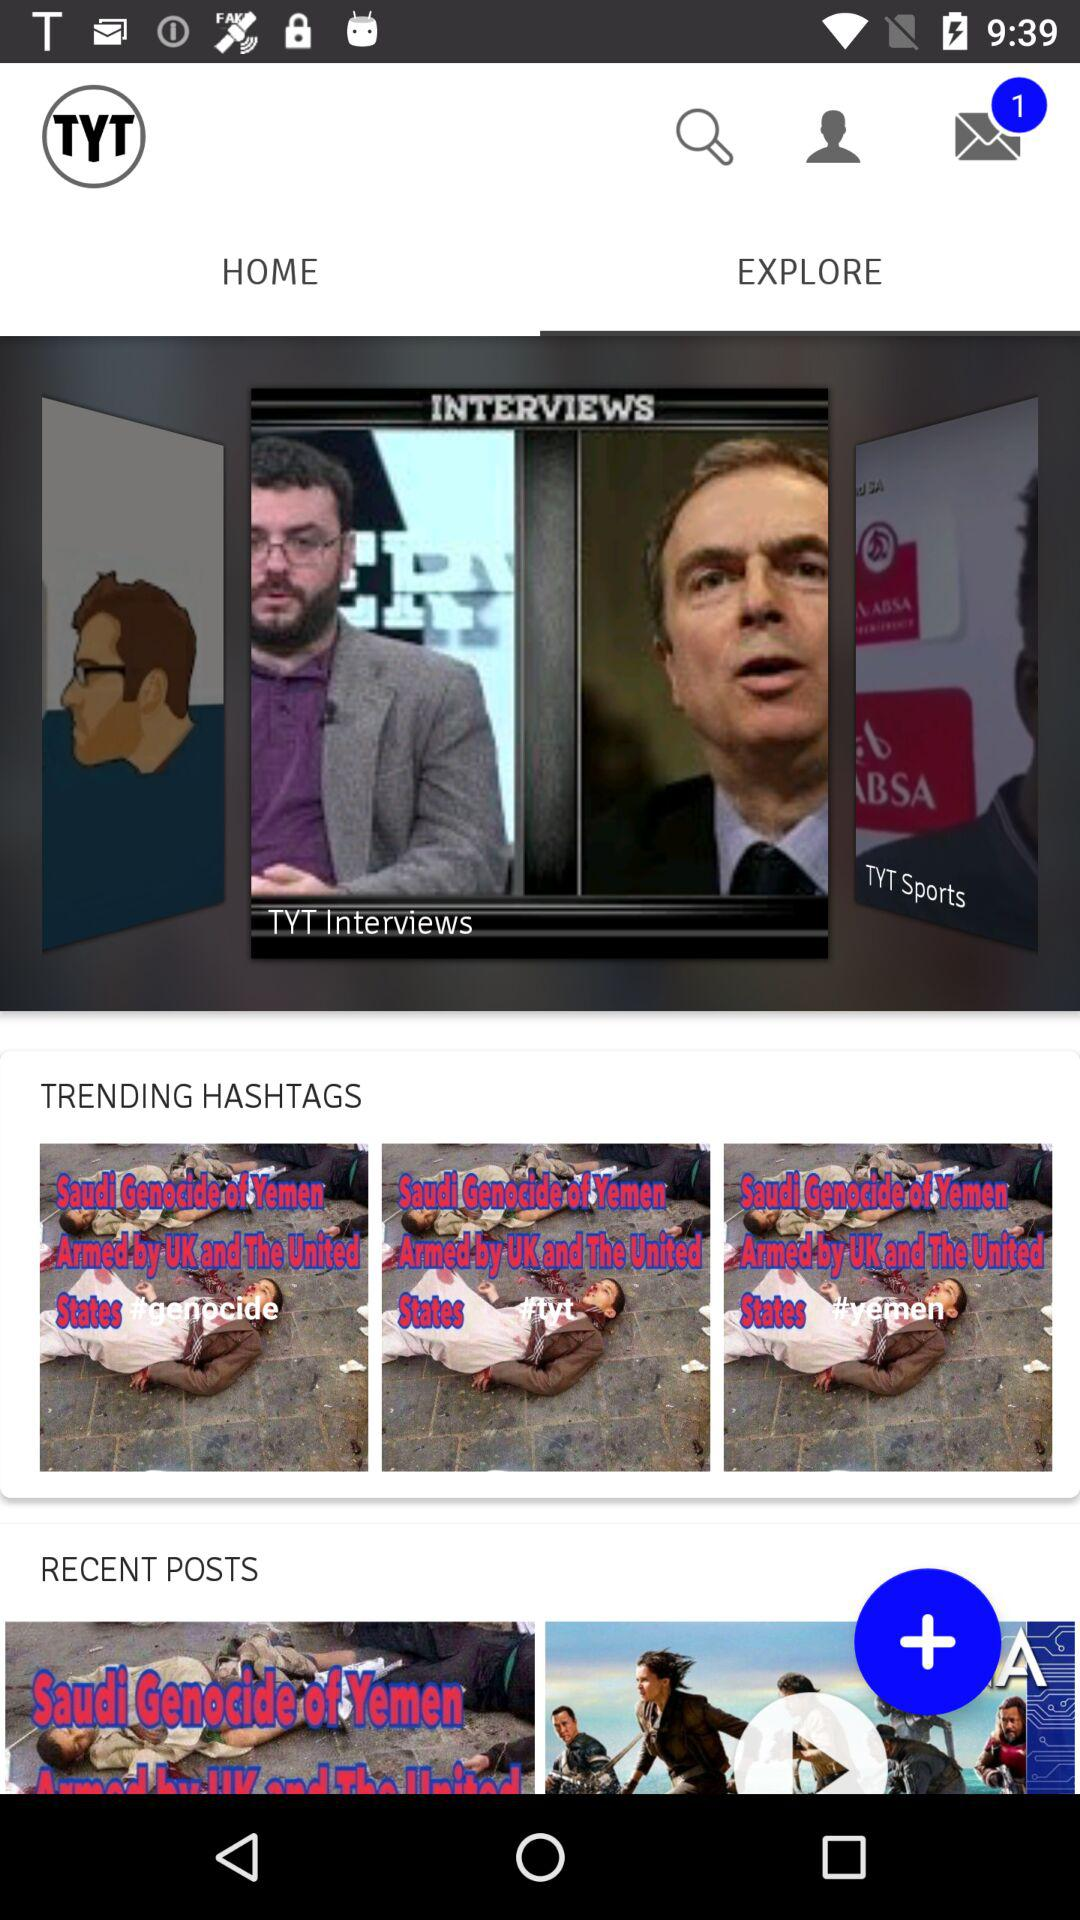How many messages are unread? There is 1 unread message. 